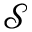Convert formula to latex. <formula><loc_0><loc_0><loc_500><loc_500>\mathcal { S }</formula> 